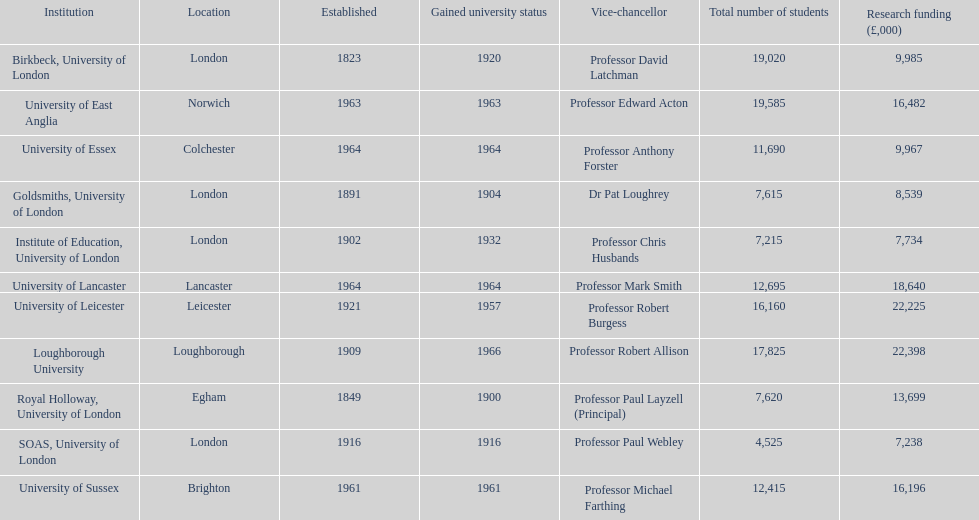Which institution has newly achieved university status? Loughborough University. 